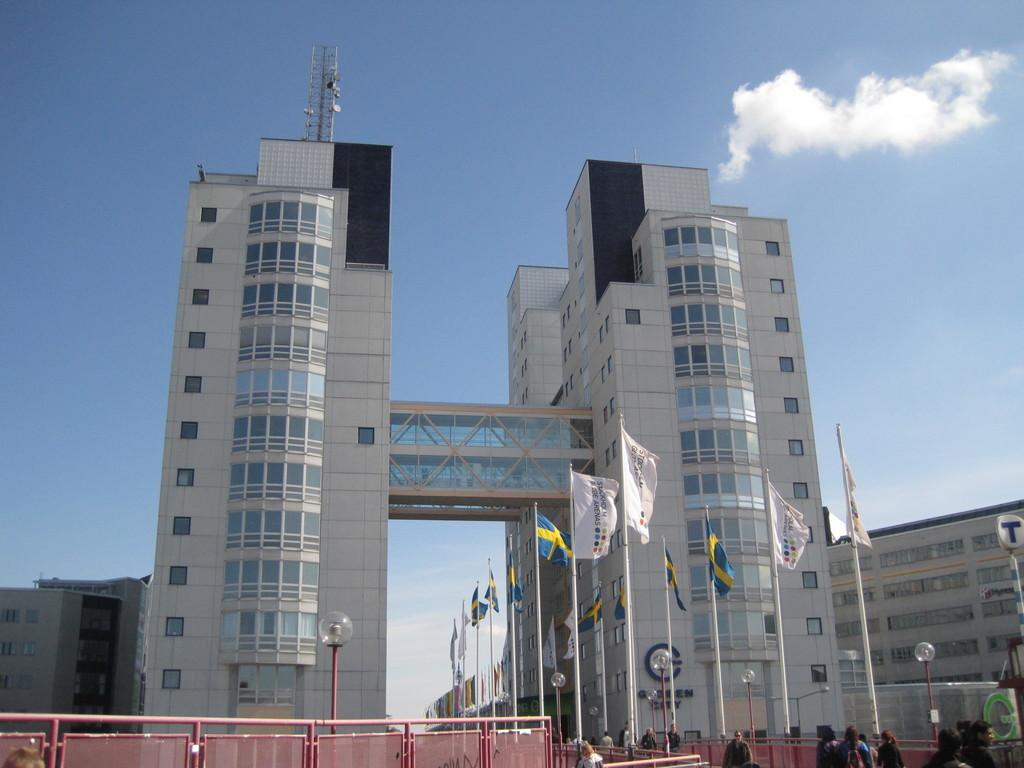What type of structures can be seen in the image? There are buildings, poles, flags, railings, and a tower in the image. What else is present in the image besides structures? There are people in the image. What can be seen in the background of the image? The sky is visible in the background of the image, and there are clouds in the sky. What is the coefficient of friction between the railings and the people in the image? The image does not provide information about the coefficient of friction between the railings and the people. --- Facts: 1. There is a car in the image. 2. The car is red. 3. The car has four wheels. 4. There are people in the car. 5. The car is parked on the street. 6. There are trees on the side of the street. Absurd Topics: dance, ocean, melody Conversation: What type of vehicle is in the image? There is a car in the image. What color is the car? The car is red. How many wheels does the car have? The car has four wheels. Who is inside the car? There are people in the car. Where is the car located? The car is parked on the street. What can be seen on the side of the street? There are trees on the side of the street. Reasoning: Let's think step by step in order to produce the conversation. We start by identifying the main subject in the image, which is the car. Then, we expand the conversation to include details about the car's color, number of wheels, and occupants. We also describe the car's location and the surrounding environment. Each question is designed to elicit a specific detail about the image that is known from the provided facts. Absurd Question/Answer: What type of dance is being performed in the car? There is no indication of any dance being performed in the car; the people inside the car are not dancing. --- Facts: 1. There is a person holding a book in the image. 2. The book has a blue cover. 3. The person is sitting on a chair. 4. There is a table next to the chair. 5. There is a lamp on the table. Absurd Topics: parrot, ocean, melody Conversation: What is the person in the image holding? The person is holding a book in the image. What color is the book's cover? The book has a blue cover. Where is the person sitting? The person is sitting on a chair. What is next to the chair? There is a table next to the chair. What is on the table? There is a lamp on the table. Reasoning: Let's think step by step in order 